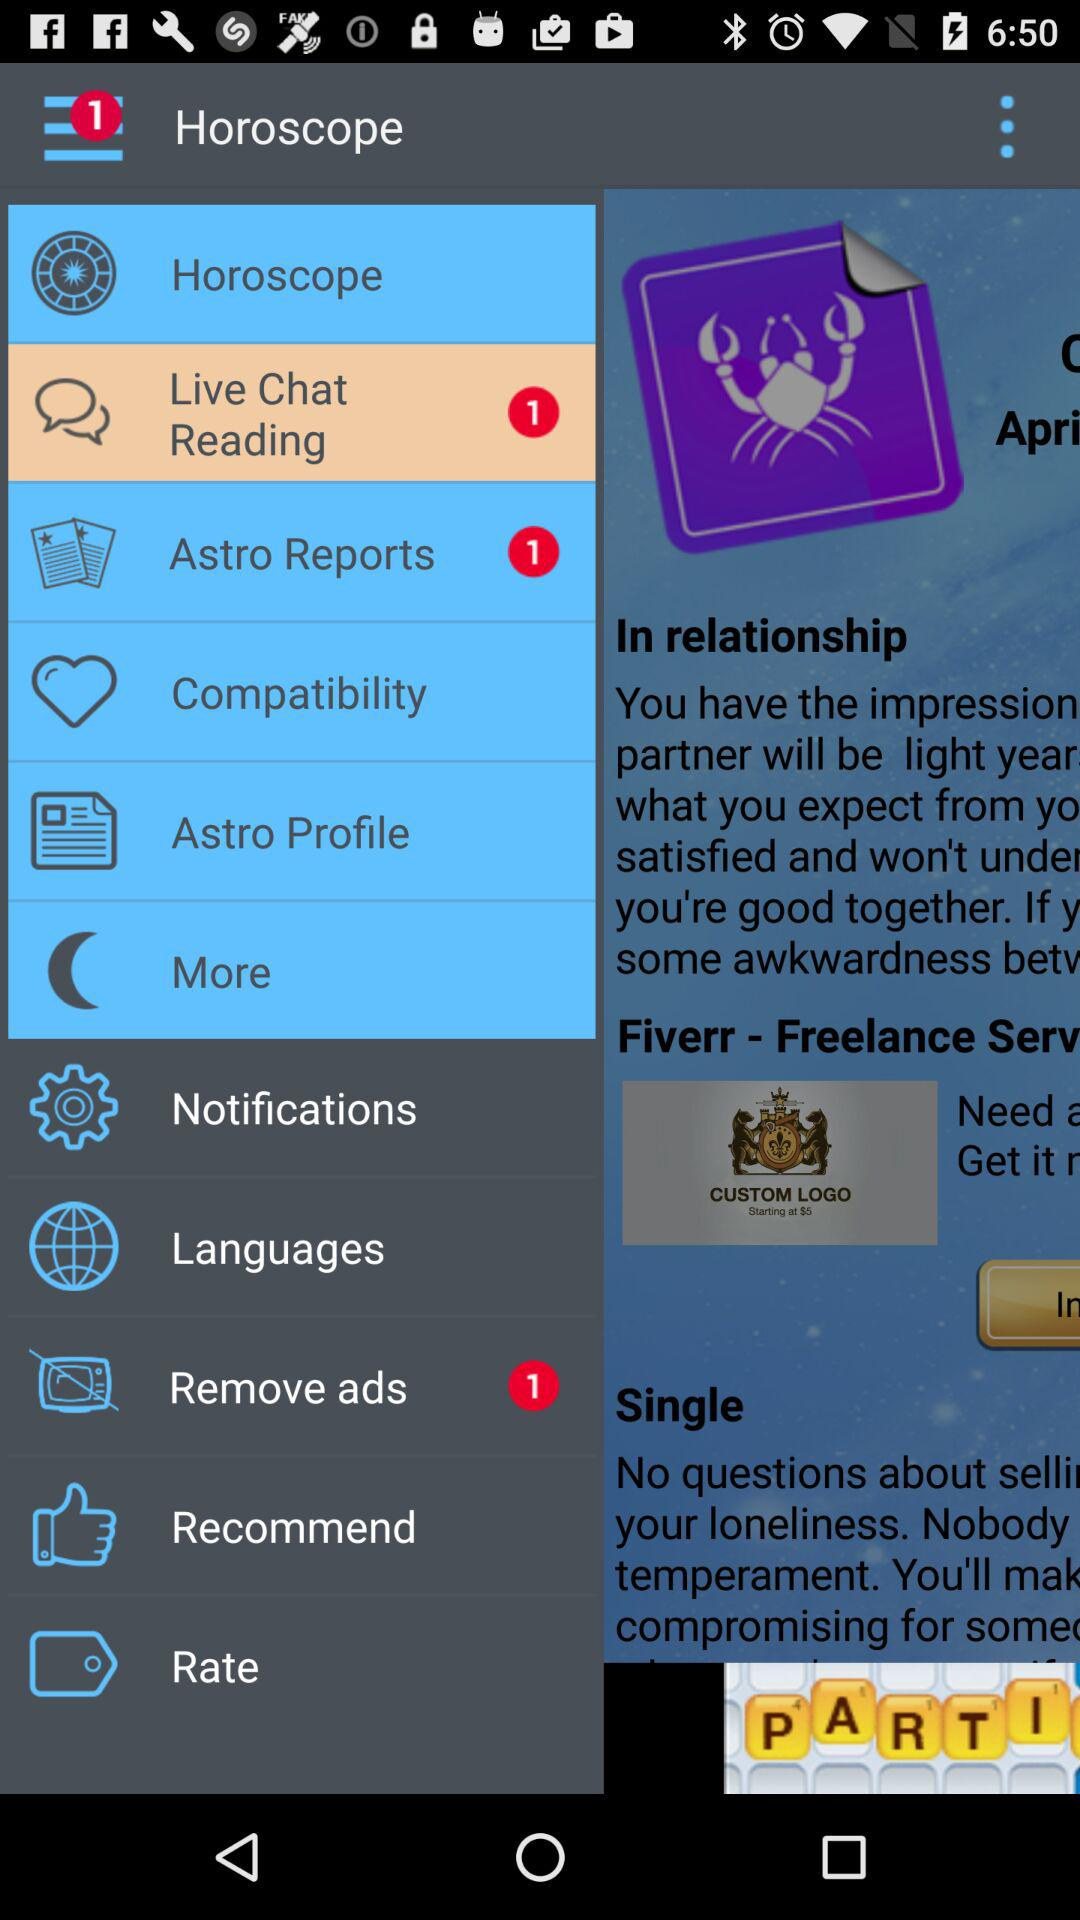How many unread notifications are there for "Remove ads"? There is 1 unread notification. 